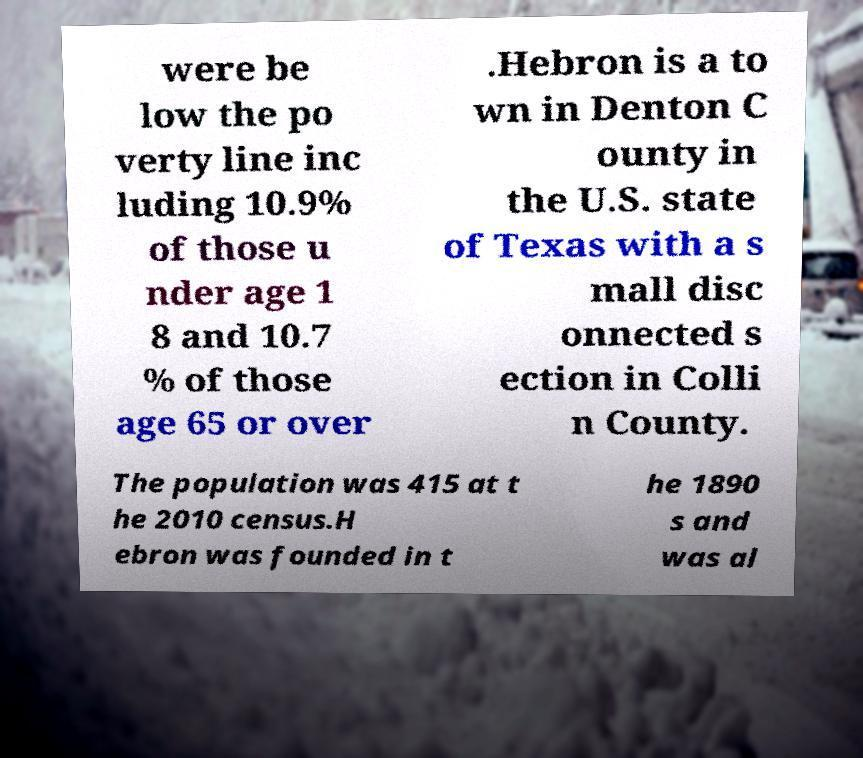For documentation purposes, I need the text within this image transcribed. Could you provide that? were be low the po verty line inc luding 10.9% of those u nder age 1 8 and 10.7 % of those age 65 or over .Hebron is a to wn in Denton C ounty in the U.S. state of Texas with a s mall disc onnected s ection in Colli n County. The population was 415 at t he 2010 census.H ebron was founded in t he 1890 s and was al 